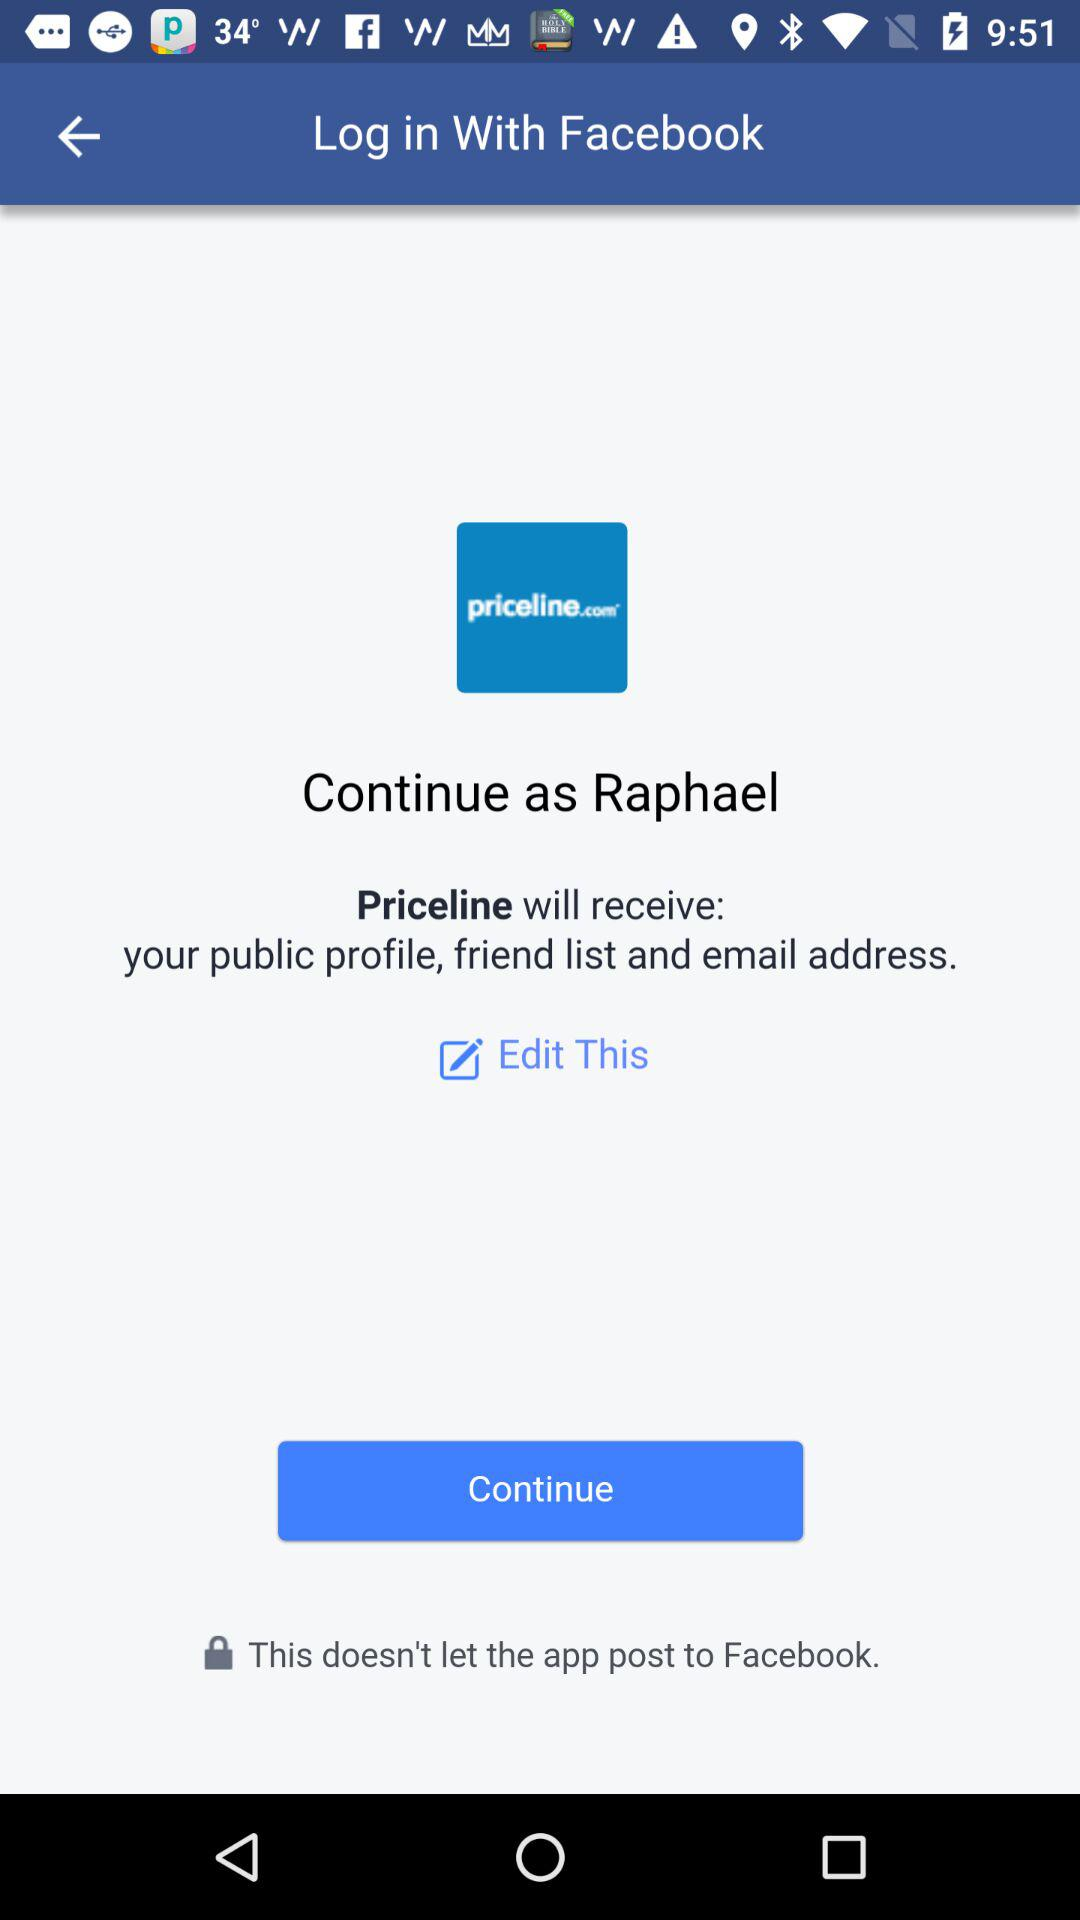What is the user name? The user name is Raphael. 